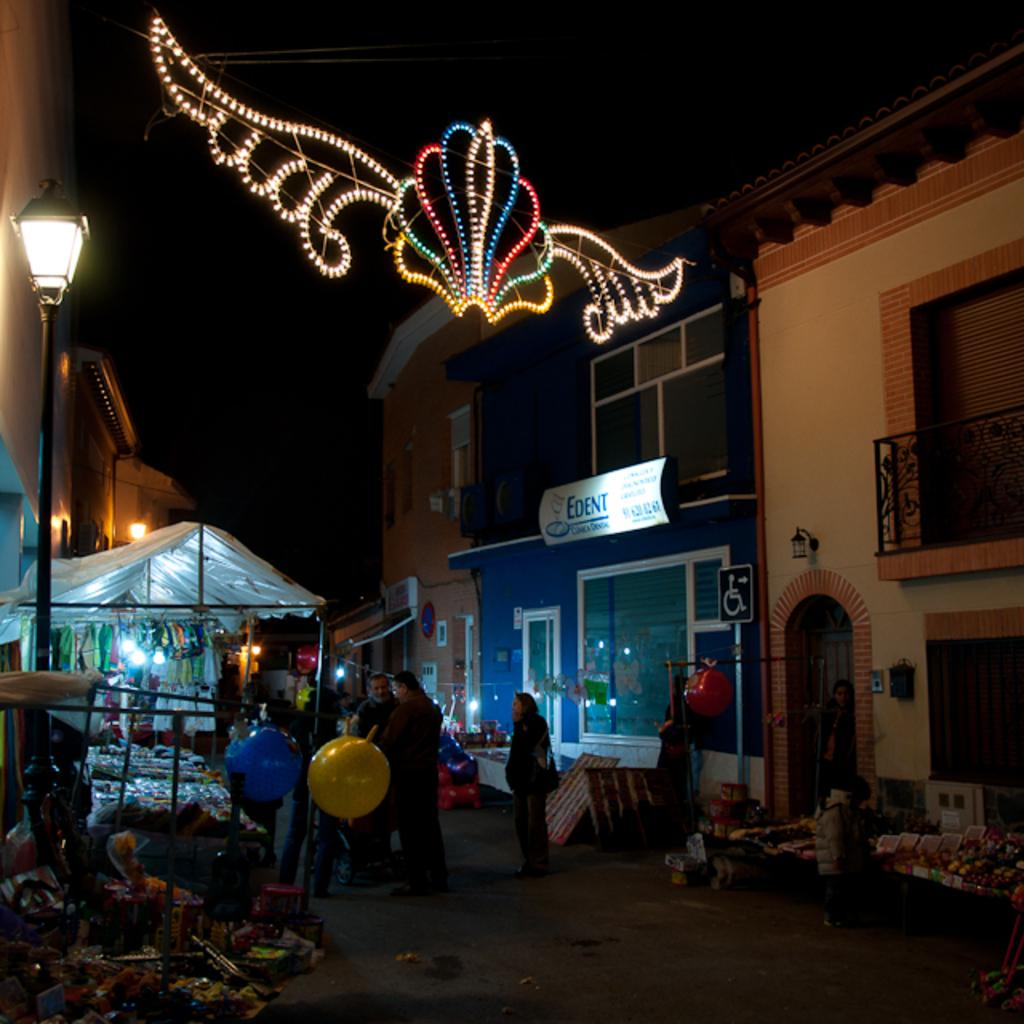What can be seen on both sides of the road in the image? There are buildings on either side of the road. What type of establishments are located in front of the houses? There are small shops in front of the houses. What structures are providing illumination in the image? There are light poles in the image. What are the people in the image doing? People are walking on the road. What type of corn is being used to paste a stranger's picture on the wall in the image? There is no corn or stranger's picture present in the image. 